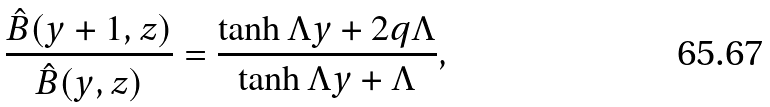<formula> <loc_0><loc_0><loc_500><loc_500>\frac { \hat { B } ( y + 1 , z ) } { \hat { B } ( y , z ) } = \frac { \tanh \Lambda y + 2 q \Lambda } { \tanh \Lambda y + \Lambda } ,</formula> 